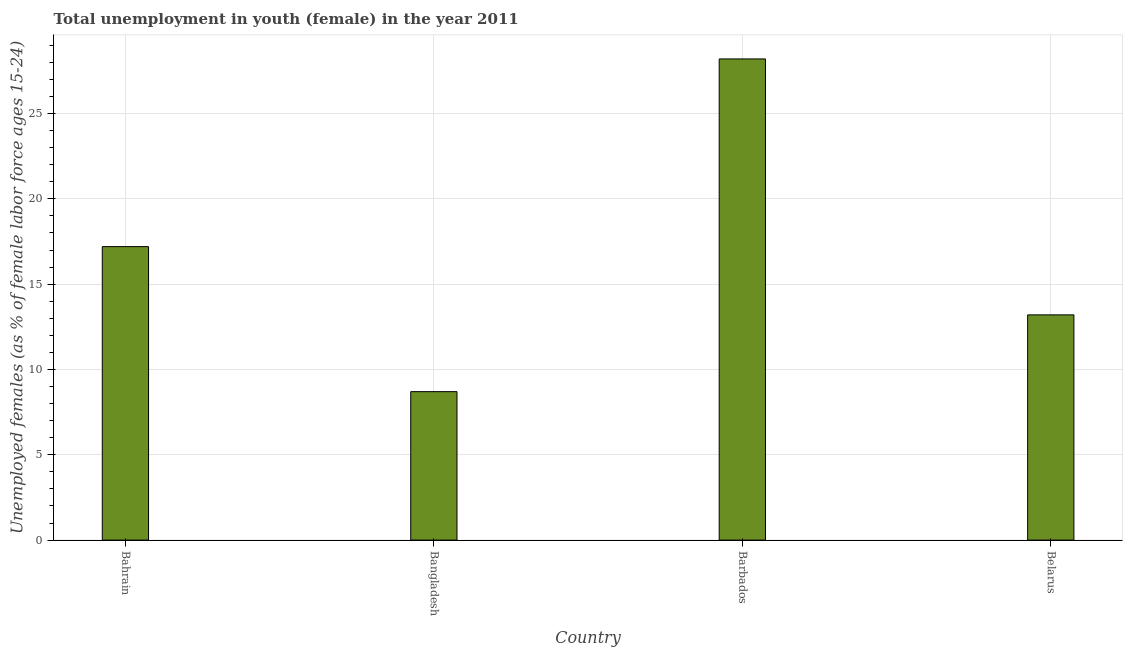What is the title of the graph?
Provide a short and direct response. Total unemployment in youth (female) in the year 2011. What is the label or title of the X-axis?
Provide a short and direct response. Country. What is the label or title of the Y-axis?
Keep it short and to the point. Unemployed females (as % of female labor force ages 15-24). What is the unemployed female youth population in Belarus?
Your answer should be very brief. 13.2. Across all countries, what is the maximum unemployed female youth population?
Provide a succinct answer. 28.2. Across all countries, what is the minimum unemployed female youth population?
Keep it short and to the point. 8.7. In which country was the unemployed female youth population maximum?
Keep it short and to the point. Barbados. In which country was the unemployed female youth population minimum?
Give a very brief answer. Bangladesh. What is the sum of the unemployed female youth population?
Your answer should be compact. 67.3. What is the difference between the unemployed female youth population in Bangladesh and Barbados?
Your response must be concise. -19.5. What is the average unemployed female youth population per country?
Your response must be concise. 16.82. What is the median unemployed female youth population?
Offer a very short reply. 15.2. What is the ratio of the unemployed female youth population in Bangladesh to that in Belarus?
Offer a very short reply. 0.66. Is the unemployed female youth population in Barbados less than that in Belarus?
Keep it short and to the point. No. What is the difference between the highest and the second highest unemployed female youth population?
Provide a short and direct response. 11. Is the sum of the unemployed female youth population in Barbados and Belarus greater than the maximum unemployed female youth population across all countries?
Provide a succinct answer. Yes. What is the difference between the highest and the lowest unemployed female youth population?
Offer a very short reply. 19.5. In how many countries, is the unemployed female youth population greater than the average unemployed female youth population taken over all countries?
Your response must be concise. 2. Are all the bars in the graph horizontal?
Provide a succinct answer. No. How many countries are there in the graph?
Ensure brevity in your answer.  4. What is the Unemployed females (as % of female labor force ages 15-24) in Bahrain?
Give a very brief answer. 17.2. What is the Unemployed females (as % of female labor force ages 15-24) in Bangladesh?
Offer a very short reply. 8.7. What is the Unemployed females (as % of female labor force ages 15-24) in Barbados?
Offer a terse response. 28.2. What is the Unemployed females (as % of female labor force ages 15-24) of Belarus?
Provide a succinct answer. 13.2. What is the difference between the Unemployed females (as % of female labor force ages 15-24) in Bahrain and Bangladesh?
Offer a very short reply. 8.5. What is the difference between the Unemployed females (as % of female labor force ages 15-24) in Bahrain and Belarus?
Give a very brief answer. 4. What is the difference between the Unemployed females (as % of female labor force ages 15-24) in Bangladesh and Barbados?
Your response must be concise. -19.5. What is the ratio of the Unemployed females (as % of female labor force ages 15-24) in Bahrain to that in Bangladesh?
Make the answer very short. 1.98. What is the ratio of the Unemployed females (as % of female labor force ages 15-24) in Bahrain to that in Barbados?
Ensure brevity in your answer.  0.61. What is the ratio of the Unemployed females (as % of female labor force ages 15-24) in Bahrain to that in Belarus?
Keep it short and to the point. 1.3. What is the ratio of the Unemployed females (as % of female labor force ages 15-24) in Bangladesh to that in Barbados?
Ensure brevity in your answer.  0.31. What is the ratio of the Unemployed females (as % of female labor force ages 15-24) in Bangladesh to that in Belarus?
Offer a terse response. 0.66. What is the ratio of the Unemployed females (as % of female labor force ages 15-24) in Barbados to that in Belarus?
Your response must be concise. 2.14. 